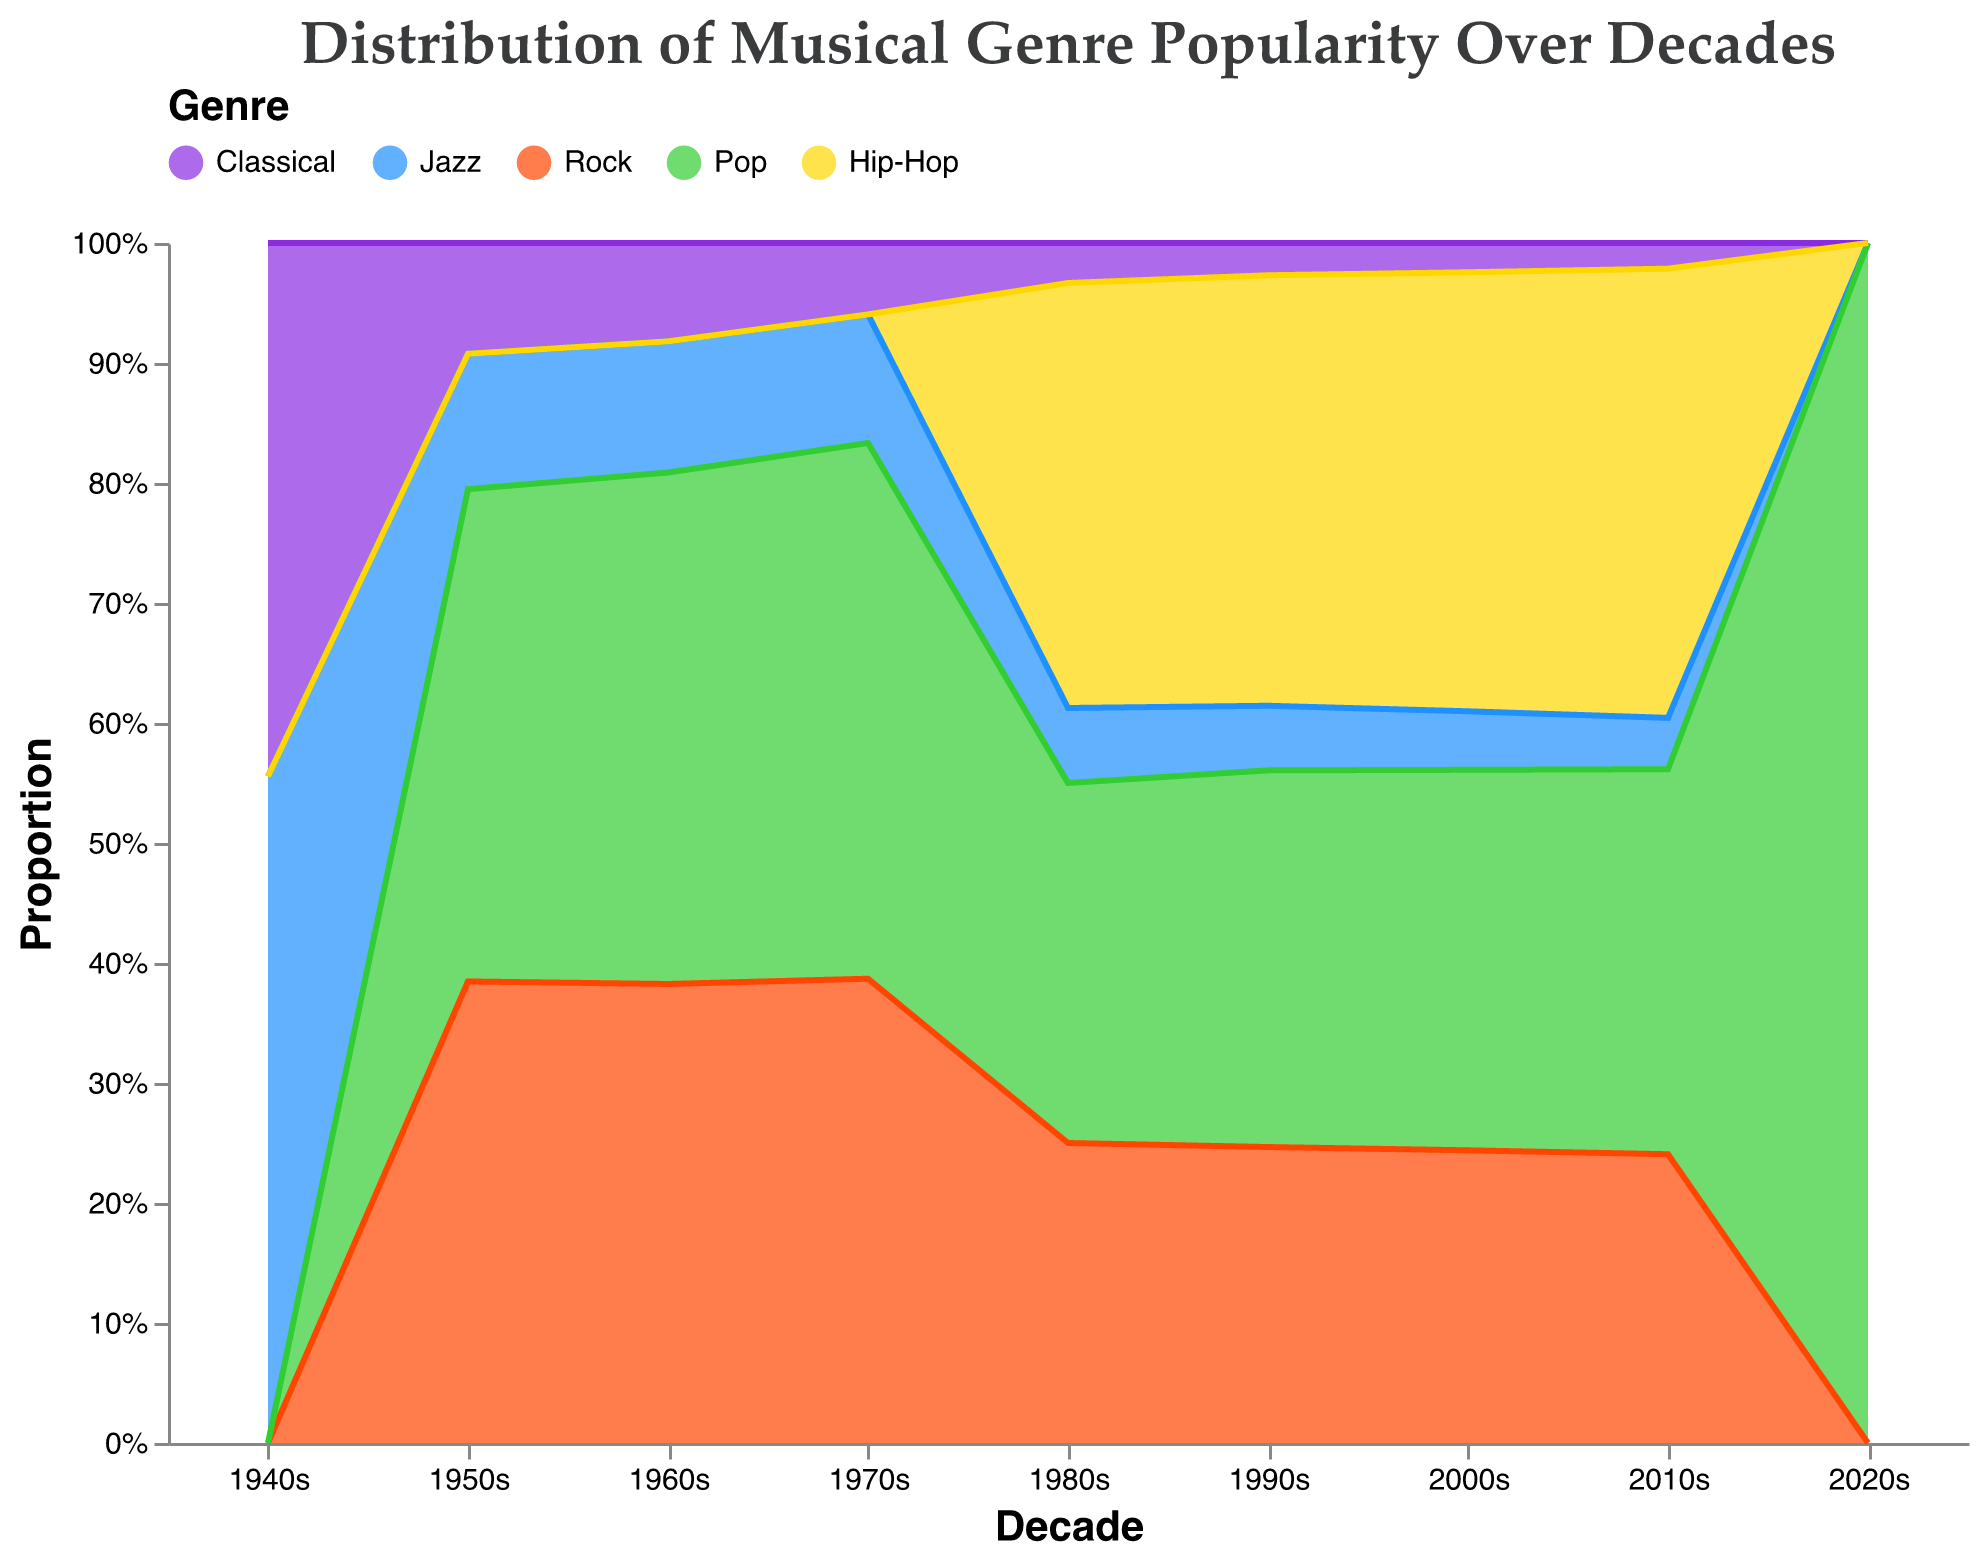What's the title of the chart? The title is located at the top of the figure and immediately draws attention.
Answer: Distribution of Musical Genre Popularity Over Decades What are the genres represented in the chart? The genres can be identified by the color legend located at the top of the chart.
Answer: Classical, Jazz, Rock, Pop, Hip-Hop Which genre shows an increasing trend in the proportion of complex harmony from the 1940s to the 2010s? By looking at the rise in the area representing complex harmony for each genre over the decades, we can spot the increasing trend.
Answer: Classical What decade shows the greatest proportion of simple harmony in the Pop genre? To find this, observe the area section of the Pop genre and identify the decade when the simple harmony portion is at its maximum.
Answer: 1950s How does the complexity of harmony in Hip-Hop change from the 1980s to the 2010s? By examining the trend line for Hip-Hop, one can see the variation in the areas denoting simple, moderate, and complex harmony over the provided decades.
Answer: Decreases in simple harmony, increases in moderate and complex harmonies Which genre shows the most consistent distribution across harmony complexity levels from the 1940s to the 2010s? Look at the areas for each harmony level within each genre and determine which genre's segments stay relatively stable over time.
Answer: Jazz Between Jazz and Rock, which genre has a higher proportion of moderate harmony in the 2000s? Compare the middle segment of both genres' areas in the 2000s to identify which is larger.
Answer: Rock What is the trend of simple harmony in Rock from the 1950s to the 2010s? Observe the bottom area labeled as "simple harmony" for Rock over these decades and note whether it grows or shrinks.
Answer: Decreases How does the proportion of complex harmony in Pop change from the 1950s to the 2020s? By following the top area segment of the Pop genre, one can observe the incremental changes in complex harmony over these years.
Answer: Increases Considering the Classical genre, how does the proportion of simple harmony in the 1940s compare to the 2010s? Compare the bottom area labeled "simple harmony" for the Classical genre in both decades.
Answer: Decreases 